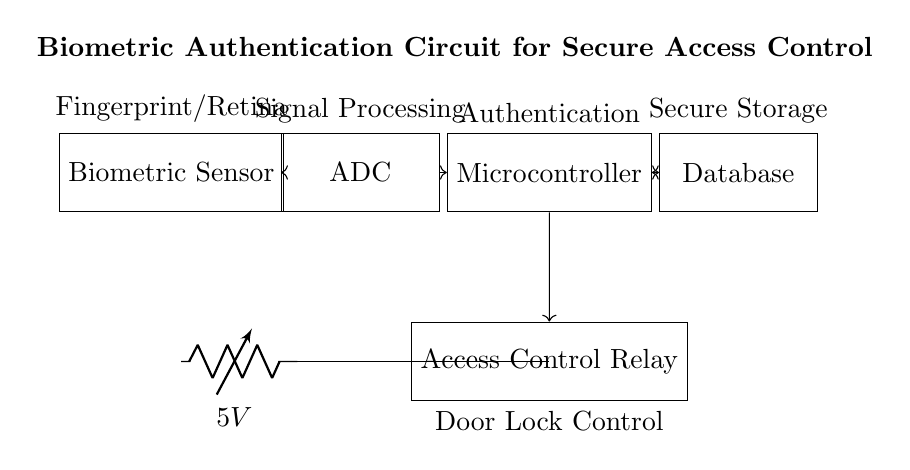What is the primary function of the biometric sensor? The biometric sensor's primary function is to capture a unique biological trait, such as a fingerprint or retina, which is used for identification and access control.
Answer: Fingerprint/Retina What component performs signal processing in this circuit? The component that performs signal processing is the Analog-to-Digital Converter (ADC), which converts the analog signal from the biometric sensor into a digital format for further processing.
Answer: ADC How many components are directly involved in the authentication process? The components directly involved in the authentication process are the biometric sensor, ADC, microcontroller, and database, totaling four components that work together to verify identity.
Answer: Four What is the purpose of the access control relay? The access control relay is responsible for controlling the door lock mechanism, activating or deactivating the lock based on the authentication decision made by the microcontroller.
Answer: Door Lock Control What is the voltage supplied to the circuit? The voltage supplied to the circuit is 5 volts, which is indicated on the battery connected to the components providing the necessary power for operation.
Answer: 5V Explain the information exchange between the microcontroller and the database. The microcontroller and the database have a bidirectional communication pathway, allowing the microcontroller to send authentication requests and receive responses regarding whether to grant or deny access based on stored biometric data.
Answer: Bidirectional communication Which component stores the biometric data securely? The component that stores the biometric data securely is the database, which holds the necessary information for the microcontroller to perform user authentication.
Answer: Database 